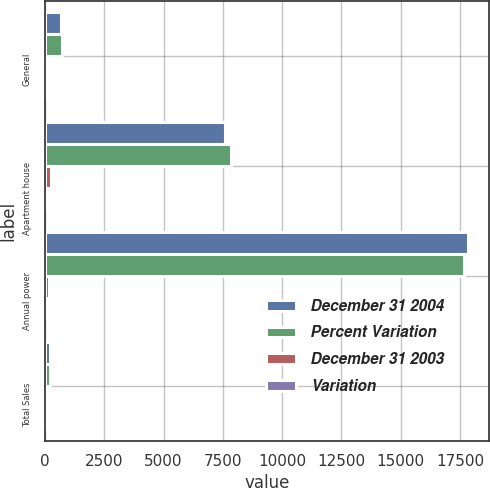Convert chart to OTSL. <chart><loc_0><loc_0><loc_500><loc_500><stacked_bar_chart><ecel><fcel>General<fcel>Apartment house<fcel>Annual power<fcel>Total Sales<nl><fcel>December 31 2004<fcel>685<fcel>7602<fcel>17842<fcel>205.5<nl><fcel>Percent Variation<fcel>729<fcel>7845<fcel>17674<fcel>205.5<nl><fcel>December 31 2003<fcel>44<fcel>243<fcel>168<fcel>119<nl><fcel>Variation<fcel>6<fcel>3.1<fcel>1<fcel>0.5<nl></chart> 